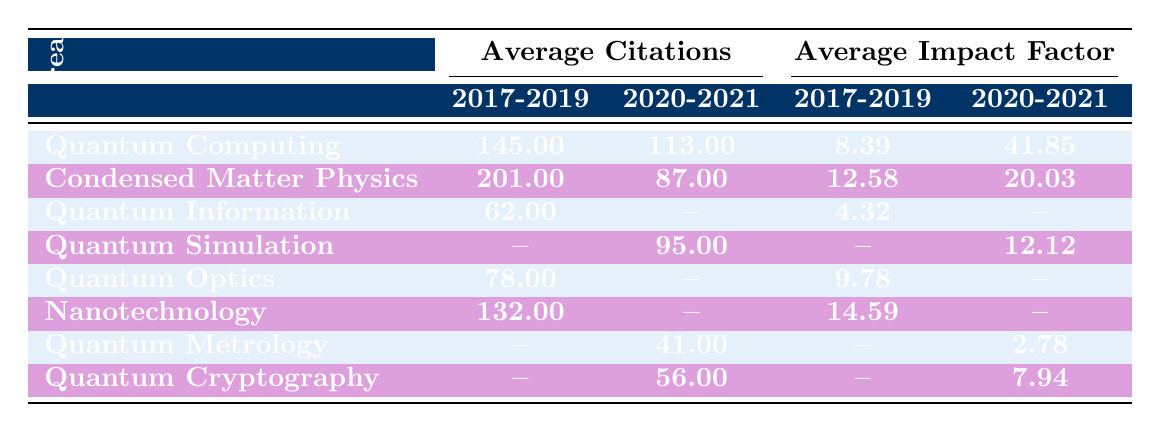What is the average number of citations for Quantum Computing papers between 2017 and 2019? The average number of citations for Quantum Computing papers in that period is given in the table as 145.00, which is directly stated under the Average Citations column for that research area.
Answer: 145.00 Which journal had the highest impact factor for papers published in 2020-2021? The highest impact factor listed in the table for papers published in 2020-2021 is 41.845, corresponding to the journal Science.
Answer: Science How many research areas have data available for 2017-2019? The research areas listed with data for 2017-2019 are Quantum Computing, Condensed Matter Physics, Quantum Information, Quantum Optics, Nanotechnology, and Quantum Metrology. This gives a total of 6 research areas with available data.
Answer: 6 Which research area experienced the highest increase in average impact factor from 2017-2019 to 2020-2021? The Quantum Computing area had an average impact factor increase from 8.39 in 2017-2019 to 41.85 in 2020-2021. This shows a significant increase of 33.46.
Answer: Quantum Computing Is there any research area with no data for both time periods, 2017-2019 and 2020-2021? No, every research area has reported data for at least one of the two time periods.
Answer: No 